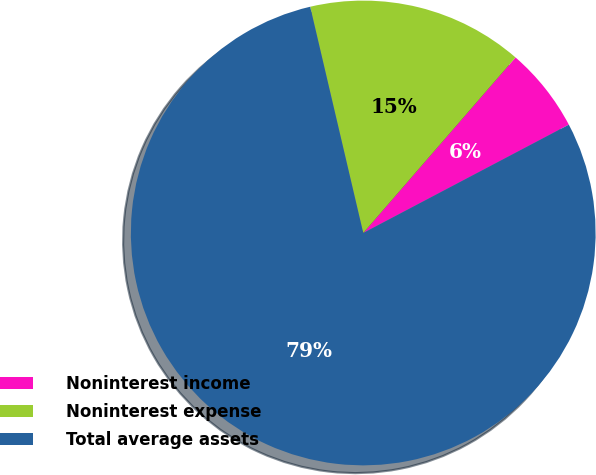<chart> <loc_0><loc_0><loc_500><loc_500><pie_chart><fcel>Noninterest income<fcel>Noninterest expense<fcel>Total average assets<nl><fcel>5.91%<fcel>15.04%<fcel>79.05%<nl></chart> 